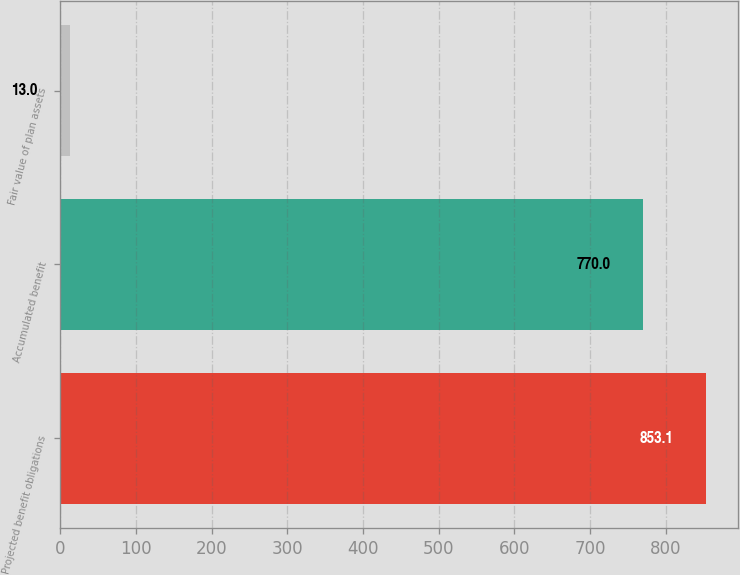<chart> <loc_0><loc_0><loc_500><loc_500><bar_chart><fcel>Projected benefit obligations<fcel>Accumulated benefit<fcel>Fair value of plan assets<nl><fcel>853.1<fcel>770<fcel>13<nl></chart> 